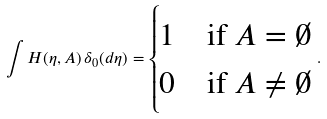Convert formula to latex. <formula><loc_0><loc_0><loc_500><loc_500>\int H ( \eta , A ) \, \delta _ { 0 } ( d \eta ) = \begin{cases} 1 & \text {if $A=\emptyset$} \\ 0 & \text {if $A\not=\emptyset$} \end{cases} .</formula> 